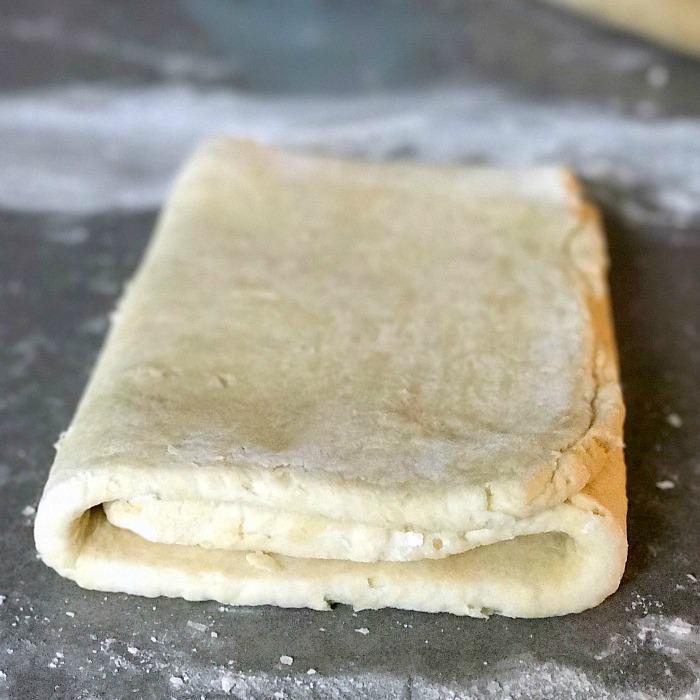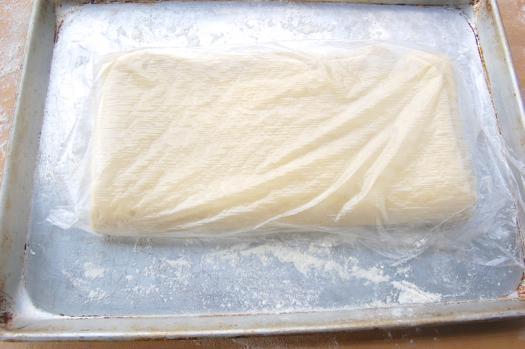The first image is the image on the left, the second image is the image on the right. For the images shown, is this caption "There is dough in plastic." true? Answer yes or no. Yes. The first image is the image on the left, the second image is the image on the right. Given the left and right images, does the statement "There are two folded pieces of dough with one in plastic." hold true? Answer yes or no. Yes. 